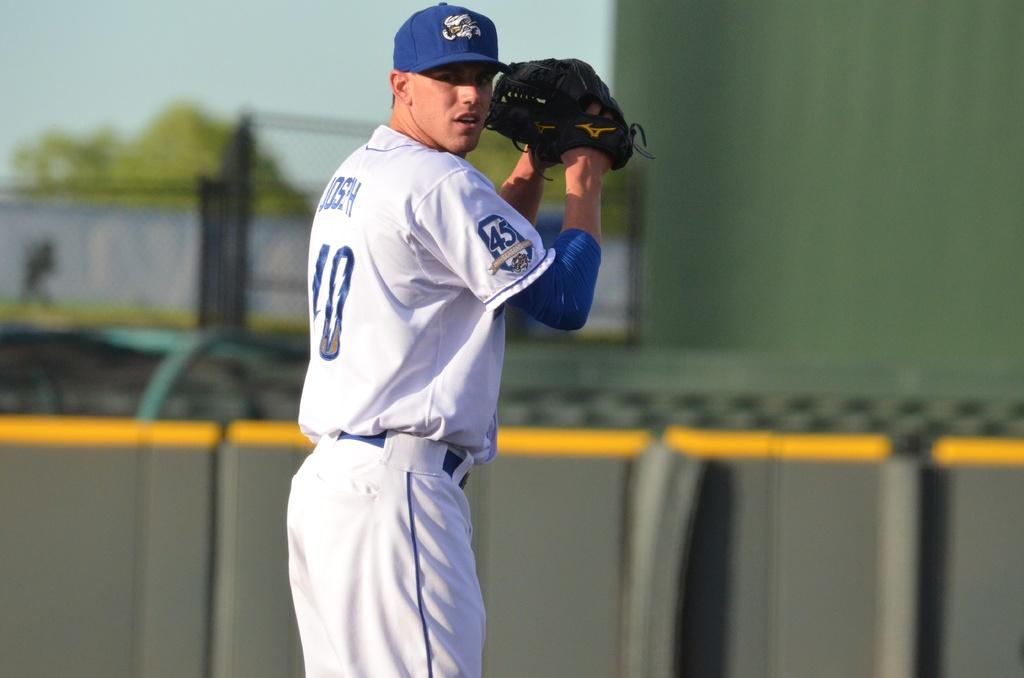<image>
Offer a succinct explanation of the picture presented. A baseball player is winding up to throw the ball and has a 45 on his jersey sleeve. 